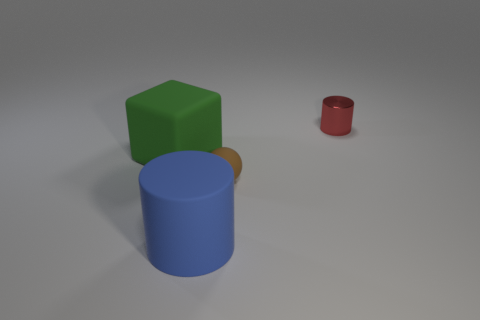Do the tiny metal object and the big rubber thing that is on the left side of the large cylinder have the same color?
Provide a succinct answer. No. Is the number of rubber objects that are behind the blue thing greater than the number of things?
Your answer should be very brief. No. How many objects are either big green blocks that are in front of the small red shiny cylinder or brown matte things in front of the red shiny thing?
Keep it short and to the point. 2. There is a cube that is the same material as the ball; what is its size?
Offer a very short reply. Large. Does the object behind the large matte block have the same shape as the brown object?
Offer a very short reply. No. What number of purple objects are tiny things or large matte things?
Give a very brief answer. 0. What number of other things are the same shape as the blue rubber object?
Your response must be concise. 1. The object that is both on the left side of the small brown thing and behind the large rubber cylinder has what shape?
Offer a very short reply. Cube. There is a red shiny cylinder; are there any red shiny things on the right side of it?
Ensure brevity in your answer.  No. There is another thing that is the same shape as the red metal thing; what size is it?
Give a very brief answer. Large. 